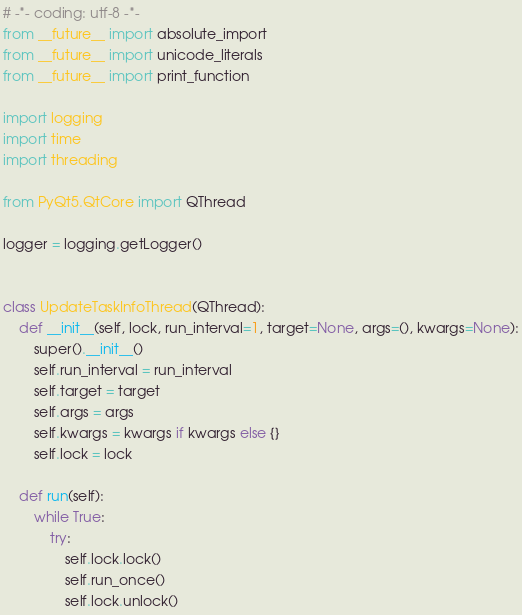<code> <loc_0><loc_0><loc_500><loc_500><_Python_># -*- coding: utf-8 -*-
from __future__ import absolute_import
from __future__ import unicode_literals
from __future__ import print_function

import logging
import time
import threading

from PyQt5.QtCore import QThread

logger = logging.getLogger()


class UpdateTaskInfoThread(QThread):
    def __init__(self, lock, run_interval=1, target=None, args=(), kwargs=None):
        super().__init__()
        self.run_interval = run_interval
        self.target = target
        self.args = args
        self.kwargs = kwargs if kwargs else {}
        self.lock = lock

    def run(self):
        while True:
            try:
                self.lock.lock()
                self.run_once()
                self.lock.unlock()</code> 